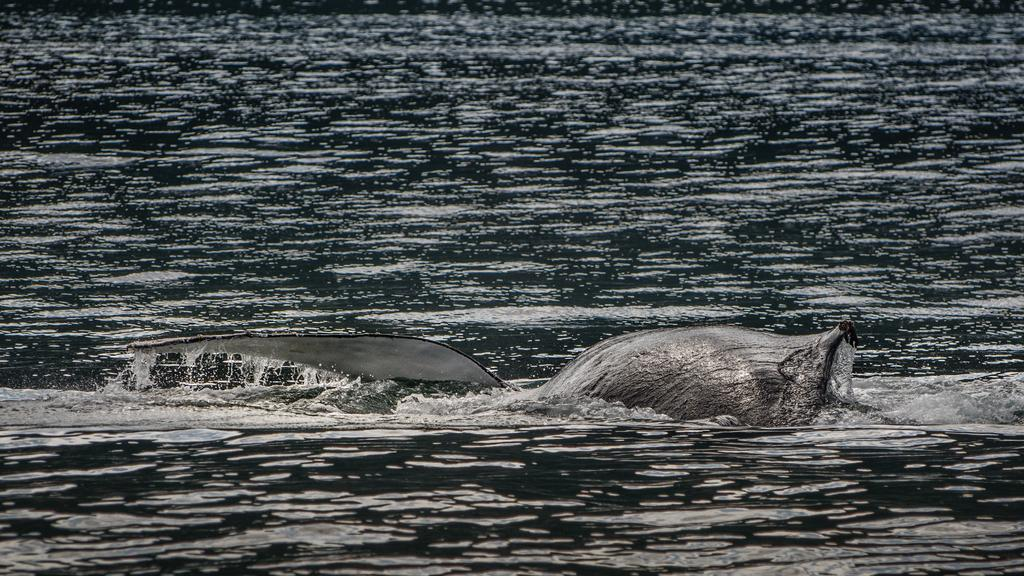What type of animal can be seen in the image? There is an aquatic animal in the image. Where is the aquatic animal located? The aquatic animal is in a water body. What type of pollution can be seen affecting the aquatic animal in the image? There is no indication of pollution in the image; it simply shows an aquatic animal in a water body. 